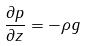Convert formula to latex. <formula><loc_0><loc_0><loc_500><loc_500>\frac { \partial p } { \partial z } = - \rho g</formula> 